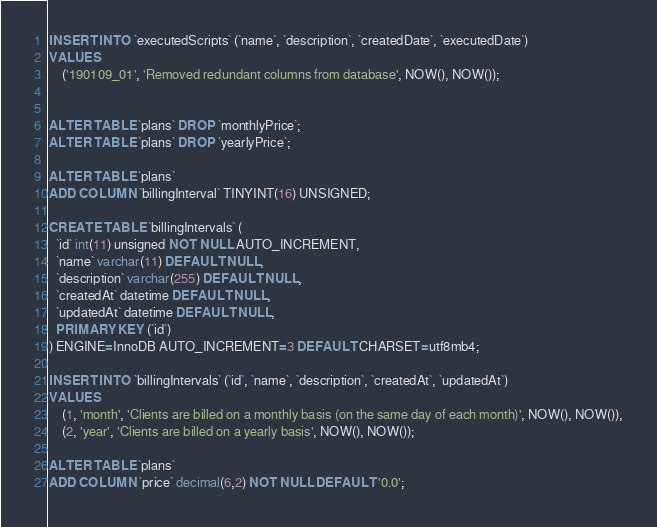Convert code to text. <code><loc_0><loc_0><loc_500><loc_500><_SQL_>INSERT INTO `executedScripts` (`name`, `description`, `createdDate`, `executedDate`)
VALUES
	('190109_01', 'Removed redundant columns from database', NOW(), NOW());


ALTER TABLE `plans` DROP `monthlyPrice`;
ALTER TABLE `plans` DROP `yearlyPrice`;

ALTER TABLE `plans`
ADD COLUMN `billingInterval` TINYINT(16) UNSIGNED;

CREATE TABLE `billingIntervals` (
  `id` int(11) unsigned NOT NULL AUTO_INCREMENT,
  `name` varchar(11) DEFAULT NULL,
  `description` varchar(255) DEFAULT NULL,
  `createdAt` datetime DEFAULT NULL,
  `updatedAt` datetime DEFAULT NULL,
  PRIMARY KEY (`id`)
) ENGINE=InnoDB AUTO_INCREMENT=3 DEFAULT CHARSET=utf8mb4;

INSERT INTO `billingIntervals` (`id`, `name`, `description`, `createdAt`, `updatedAt`)
VALUES
	(1, 'month', 'Clients are billed on a monthly basis (on the same day of each month)', NOW(), NOW()),
	(2, 'year', 'Clients are billed on a yearly basis', NOW(), NOW());

ALTER TABLE `plans`
ADD COLUMN `price` decimal(6,2) NOT NULL DEFAULT '0.0';</code> 